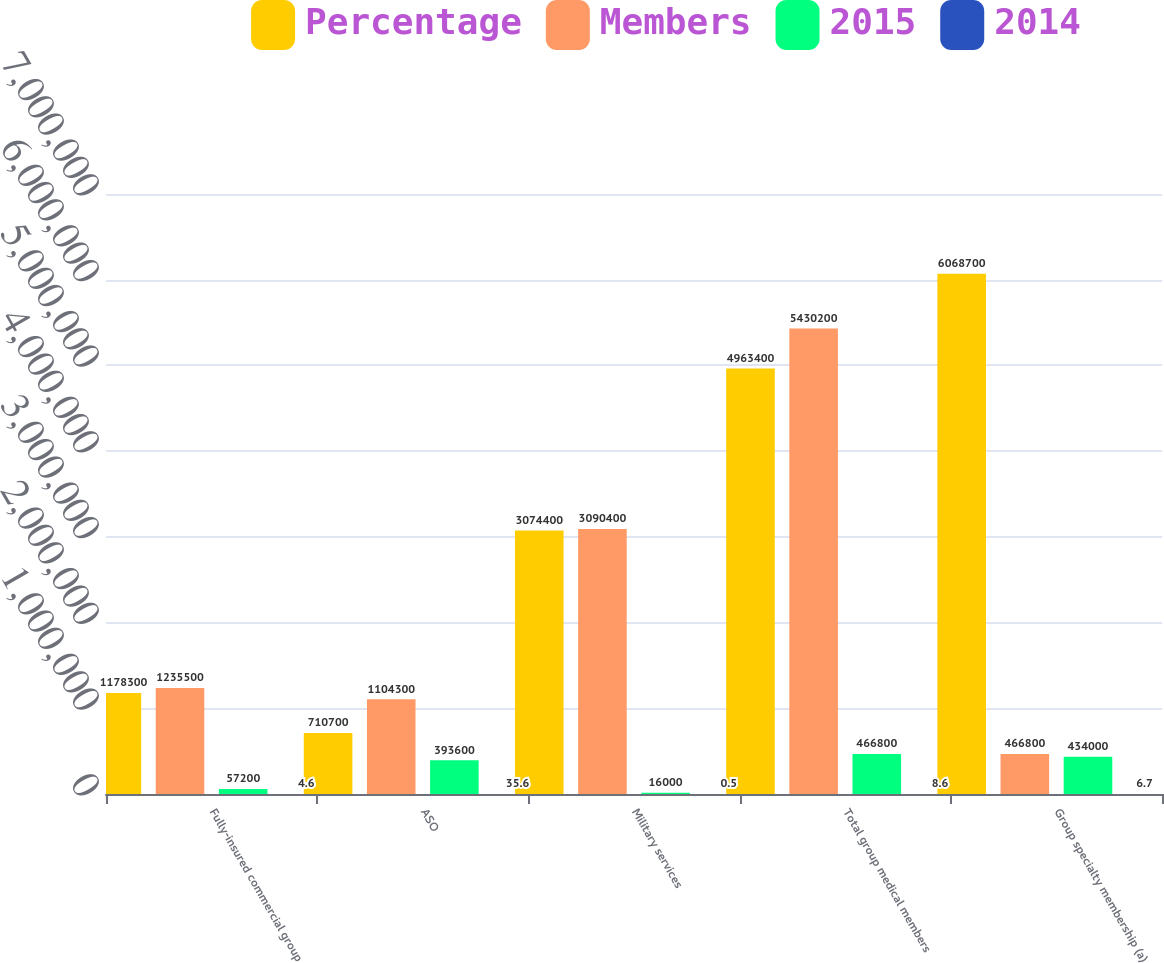<chart> <loc_0><loc_0><loc_500><loc_500><stacked_bar_chart><ecel><fcel>Fully-insured commercial group<fcel>ASO<fcel>Military services<fcel>Total group medical members<fcel>Group specialty membership (a)<nl><fcel>Percentage<fcel>1.1783e+06<fcel>710700<fcel>3.0744e+06<fcel>4.9634e+06<fcel>6.0687e+06<nl><fcel>Members<fcel>1.2355e+06<fcel>1.1043e+06<fcel>3.0904e+06<fcel>5.4302e+06<fcel>466800<nl><fcel>2015<fcel>57200<fcel>393600<fcel>16000<fcel>466800<fcel>434000<nl><fcel>2014<fcel>4.6<fcel>35.6<fcel>0.5<fcel>8.6<fcel>6.7<nl></chart> 